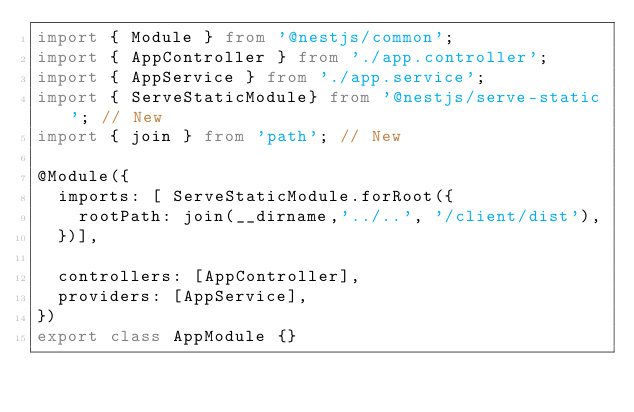<code> <loc_0><loc_0><loc_500><loc_500><_TypeScript_>import { Module } from '@nestjs/common';
import { AppController } from './app.controller';
import { AppService } from './app.service';
import { ServeStaticModule} from '@nestjs/serve-static'; // New
import { join } from 'path'; // New

@Module({
  imports: [ ServeStaticModule.forRoot({ 
    rootPath: join(__dirname,'../..', '/client/dist'),
  })],

  controllers: [AppController],
  providers: [AppService],
})
export class AppModule {}
</code> 